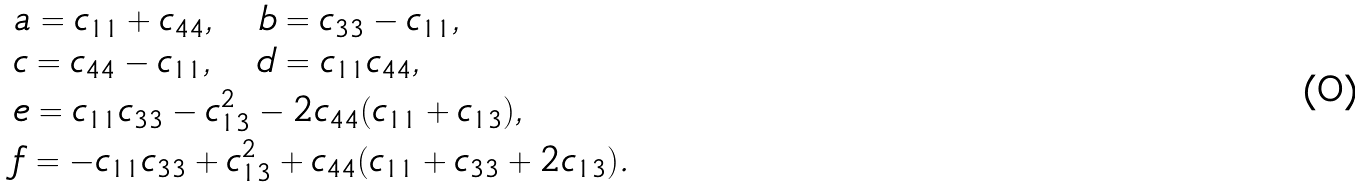<formula> <loc_0><loc_0><loc_500><loc_500>& a = c _ { 1 1 } + c _ { 4 4 } , \quad b = c _ { 3 3 } - c _ { 1 1 } , \\ & c = c _ { 4 4 } - c _ { 1 1 } , \quad d = c _ { 1 1 } c _ { 4 4 } , \\ & e = c _ { 1 1 } c _ { 3 3 } - c _ { 1 3 } ^ { 2 } - 2 c _ { 4 4 } ( c _ { 1 1 } + c _ { 1 3 } ) , \\ & f = - c _ { 1 1 } c _ { 3 3 } + c _ { 1 3 } ^ { 2 } + c _ { 4 4 } ( c _ { 1 1 } + c _ { 3 3 } + 2 c _ { 1 3 } ) .</formula> 